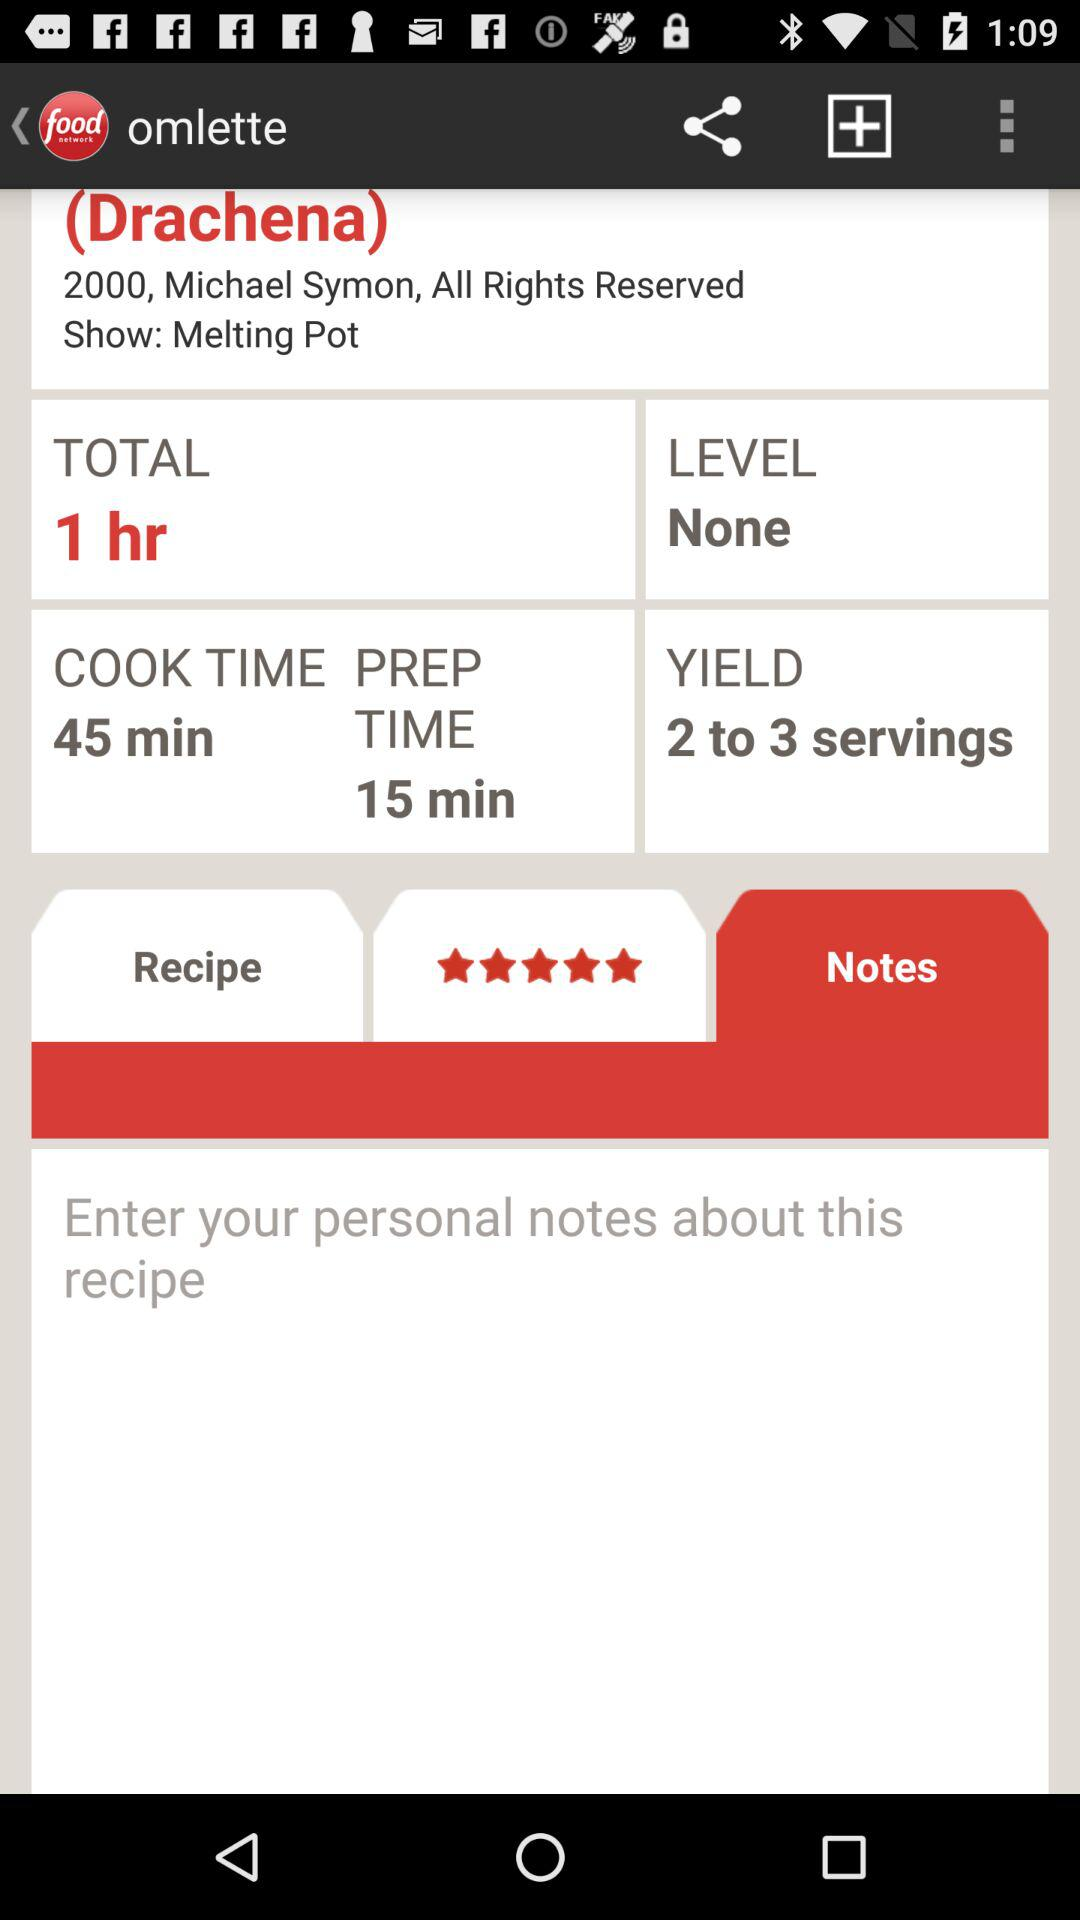What is the name of the recipe? The name of the recipe is "Drachena". 